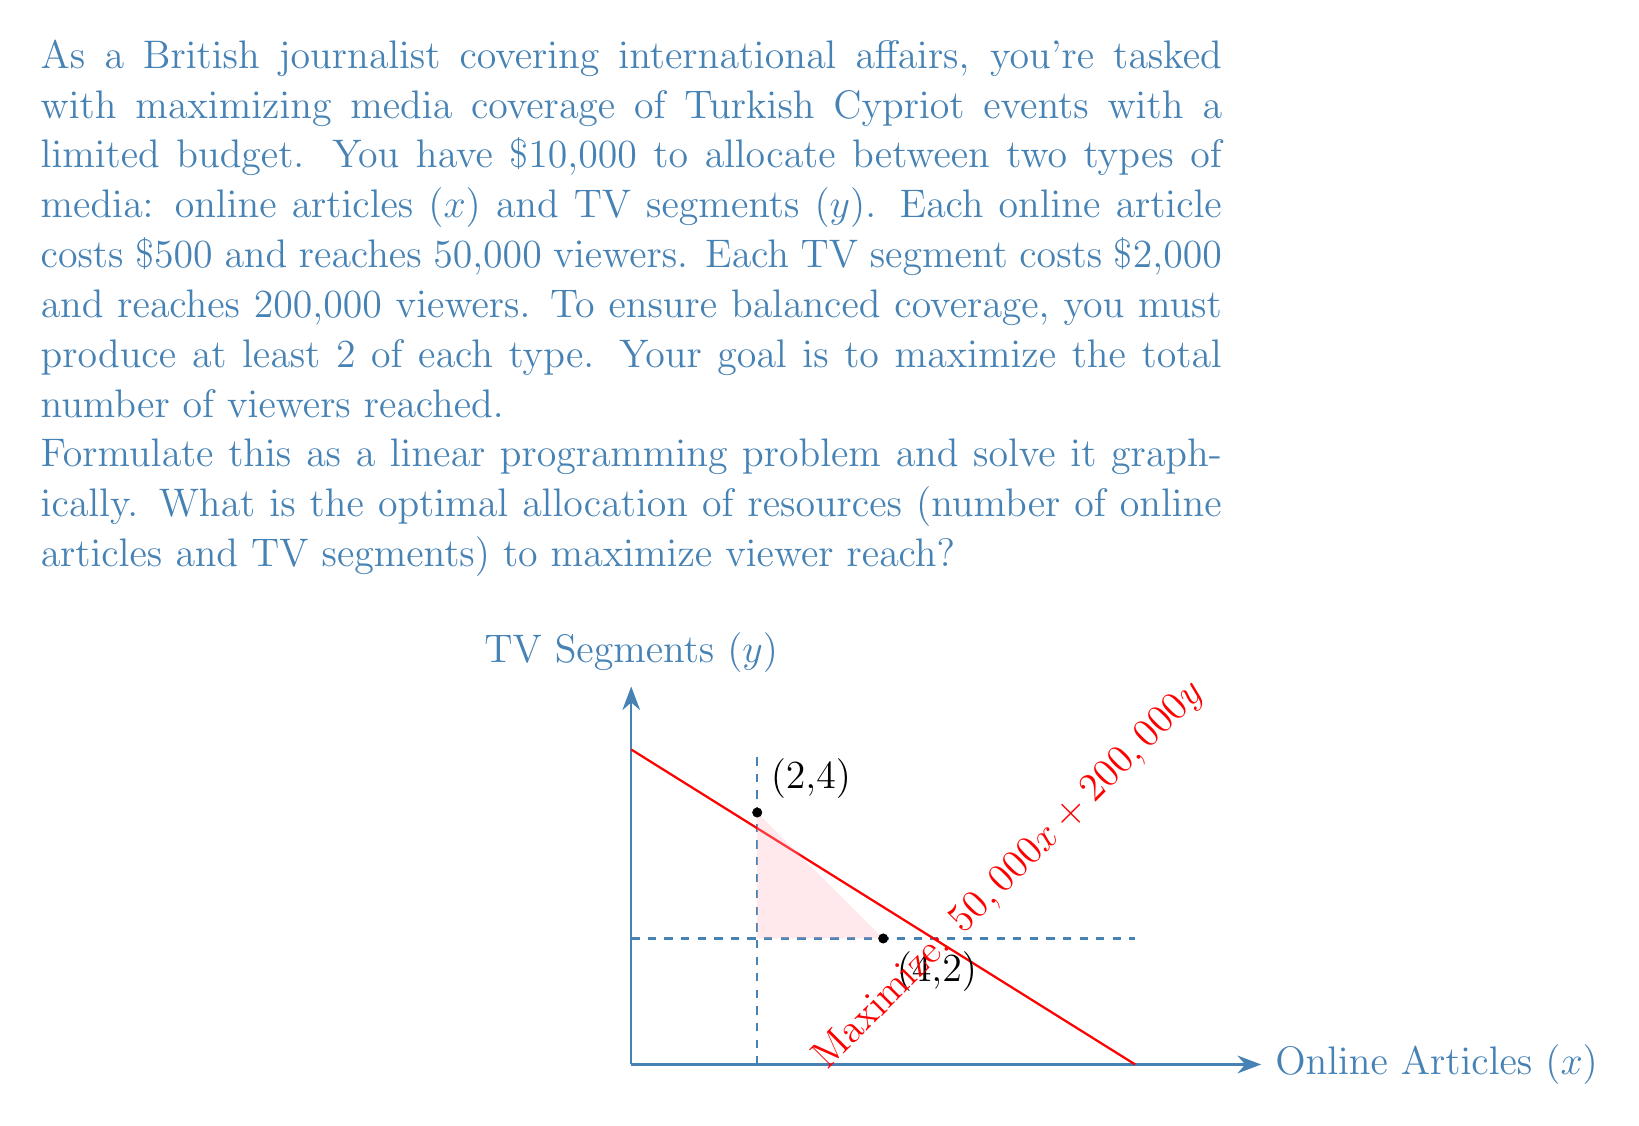Show me your answer to this math problem. Let's approach this step-by-step:

1) Define variables:
   $x$ = number of online articles
   $y$ = number of TV segments

2) Objective function:
   Maximize $Z = 50,000x + 200,000y$ (total viewers reached)

3) Constraints:
   Budget: $500x + 2000y \leq 10000$
   Minimum requirements: $x \geq 2$ and $y \geq 2$
   Non-negativity: $x, y \geq 0$

4) Simplify the budget constraint:
   $500x + 2000y \leq 10000$
   $x + 4y \leq 20$

5) Plot the constraints:
   $x \geq 2$ is a vertical line at $x = 2$
   $y \geq 2$ is a horizontal line at $y = 2$
   $x + 4y = 20$ is the budget line

6) The feasible region is the triangle bounded by these lines.

7) The optimal solution will be at one of the corner points of this triangle. The corners are (2,2), (2,4), and (4,2).

8) Evaluate the objective function at each point:
   At (2,2): $Z = 50,000(2) + 200,000(2) = 500,000$
   At (2,4): $Z = 50,000(2) + 200,000(4) = 900,000$
   At (4,2): $Z = 50,000(4) + 200,000(2) = 600,000$

9) The maximum value occurs at (2,4), which represents 2 online articles and 4 TV segments.
Answer: 2 online articles, 4 TV segments 